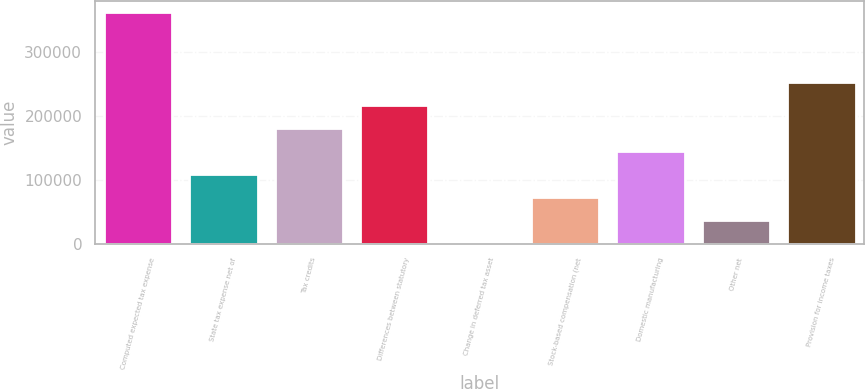Convert chart to OTSL. <chart><loc_0><loc_0><loc_500><loc_500><bar_chart><fcel>Computed expected tax expense<fcel>State tax expense net of<fcel>Tax credits<fcel>Differences between statutory<fcel>Change in deferred tax asset<fcel>Stock-based compensation (net<fcel>Domestic manufacturing<fcel>Other net<fcel>Provision for income taxes<nl><fcel>362331<fcel>109044<fcel>181412<fcel>217596<fcel>493<fcel>72860.6<fcel>145228<fcel>36676.8<fcel>253780<nl></chart> 